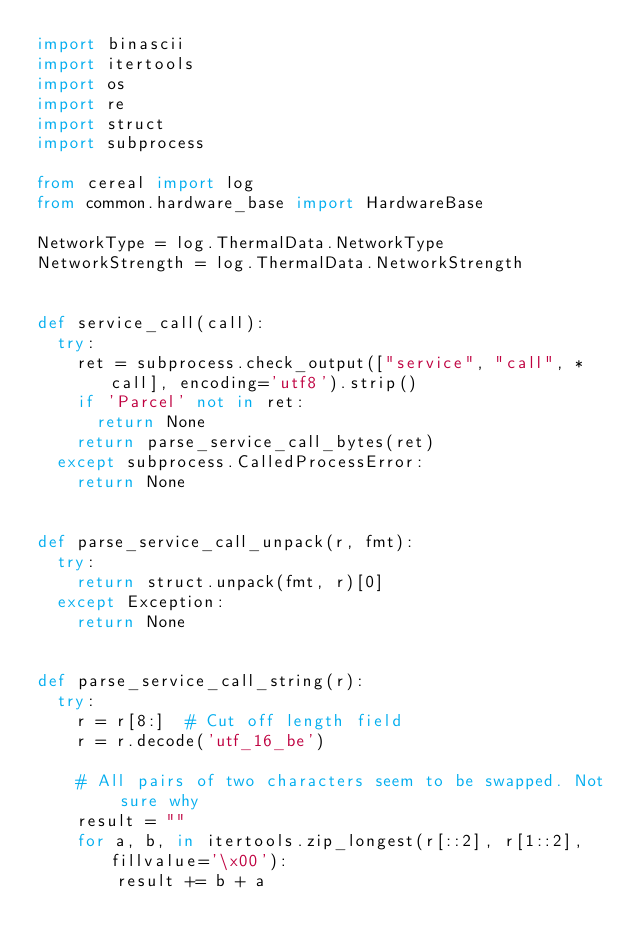Convert code to text. <code><loc_0><loc_0><loc_500><loc_500><_Python_>import binascii
import itertools
import os
import re
import struct
import subprocess

from cereal import log
from common.hardware_base import HardwareBase

NetworkType = log.ThermalData.NetworkType
NetworkStrength = log.ThermalData.NetworkStrength


def service_call(call):
  try:
    ret = subprocess.check_output(["service", "call", *call], encoding='utf8').strip()
    if 'Parcel' not in ret:
      return None
    return parse_service_call_bytes(ret)
  except subprocess.CalledProcessError:
    return None


def parse_service_call_unpack(r, fmt):
  try:
    return struct.unpack(fmt, r)[0]
  except Exception:
    return None


def parse_service_call_string(r):
  try:
    r = r[8:]  # Cut off length field
    r = r.decode('utf_16_be')

    # All pairs of two characters seem to be swapped. Not sure why
    result = ""
    for a, b, in itertools.zip_longest(r[::2], r[1::2], fillvalue='\x00'):
        result += b + a
</code> 